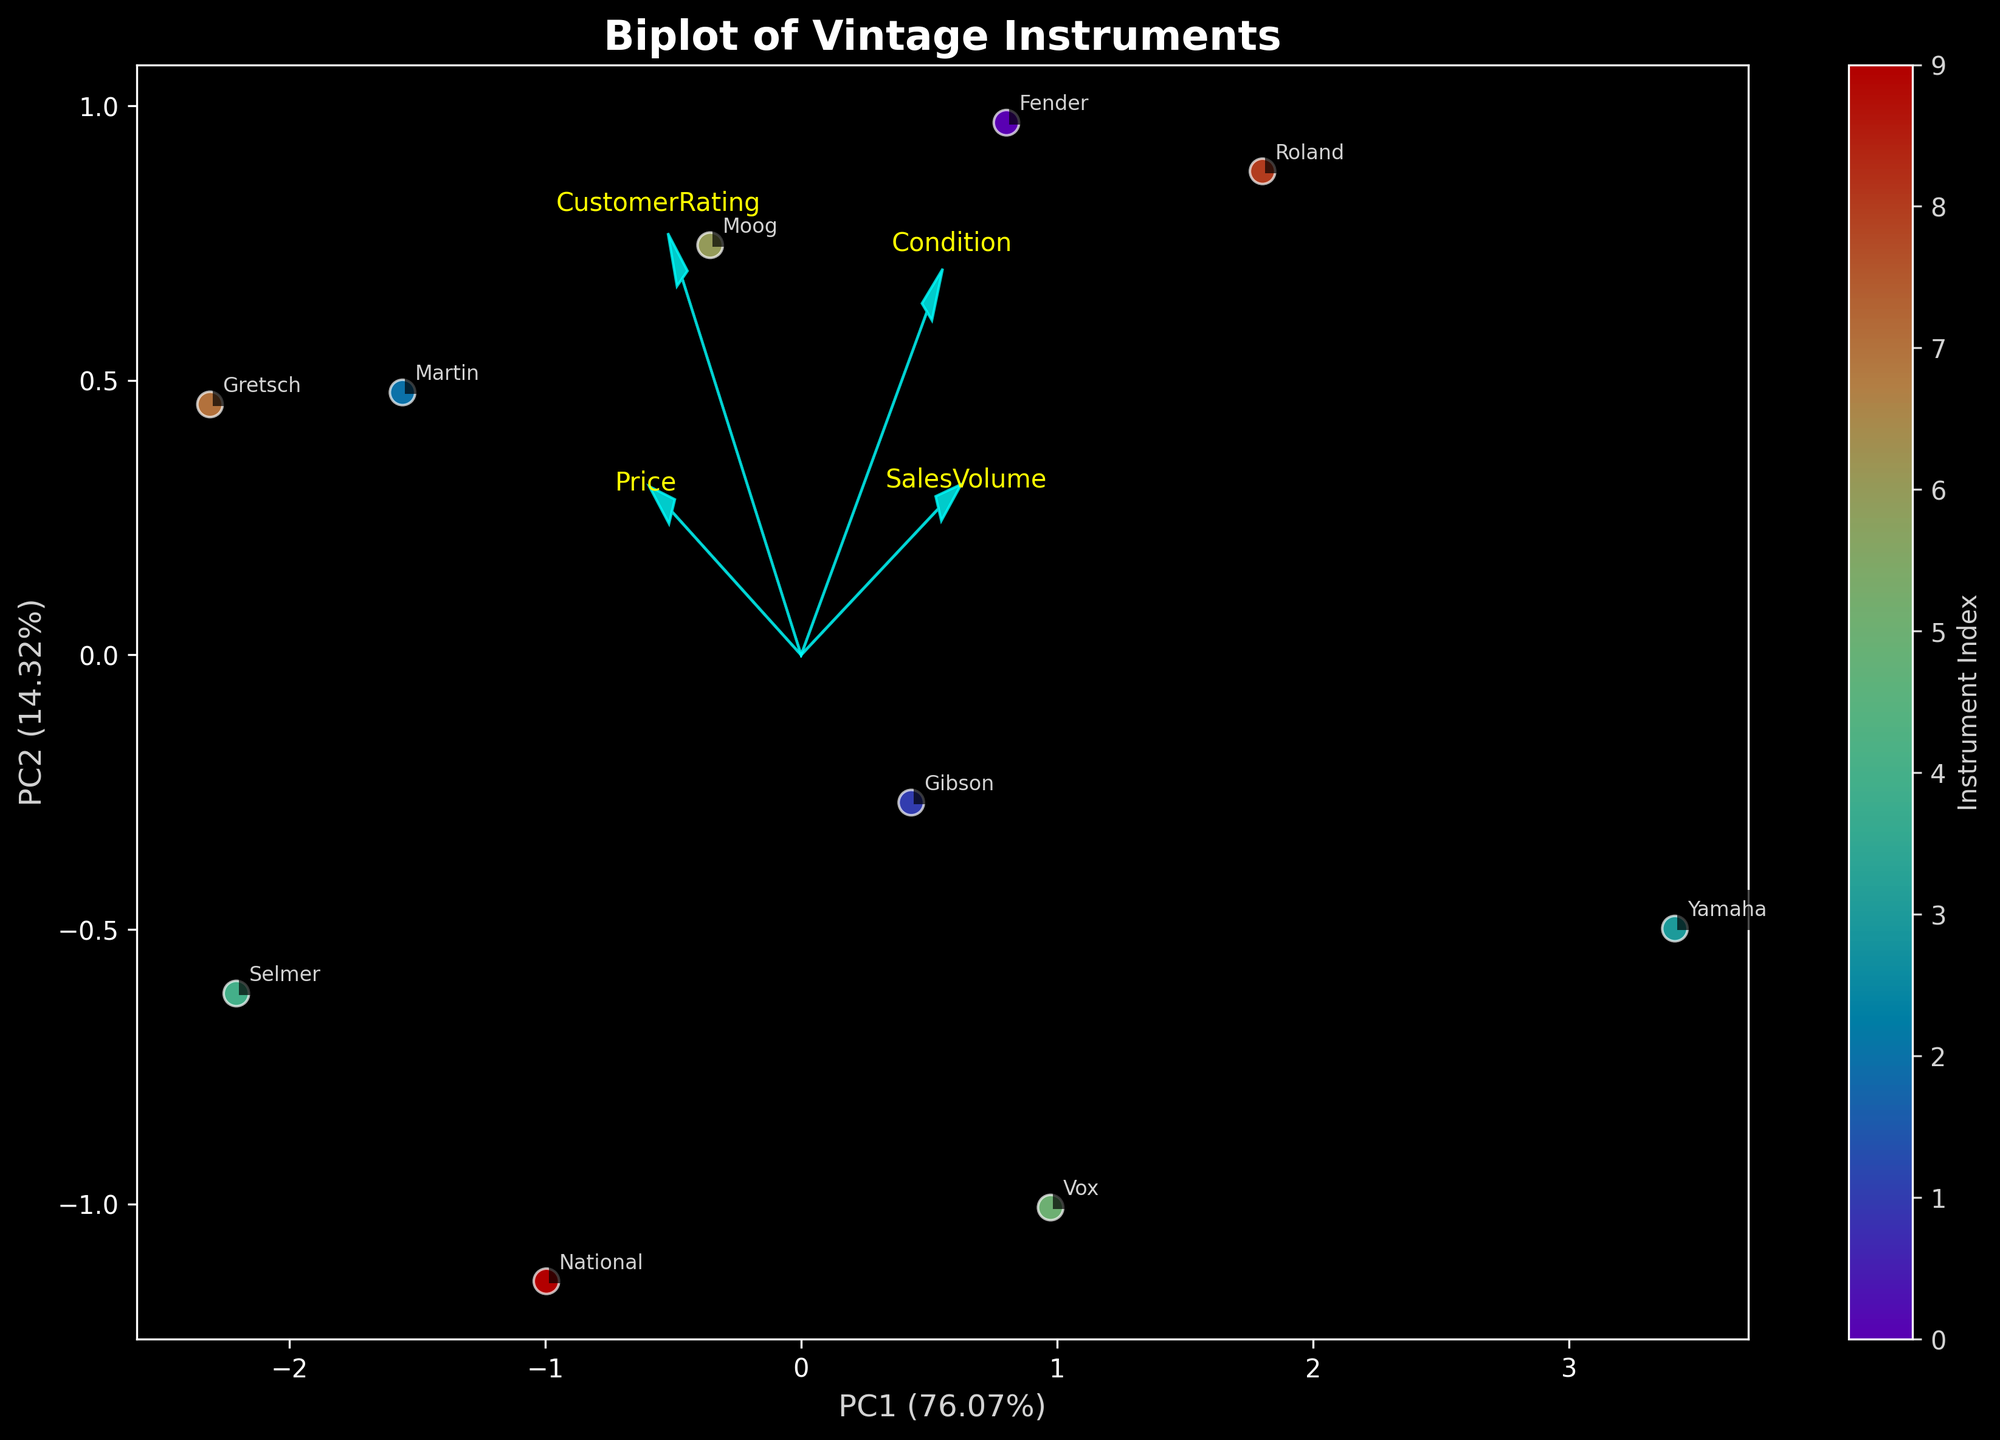What is the title of the figure? The title of the figure is usually displayed prominently at the top. In this case, it says "Biplot of Vintage Instruments."
Answer: Biplot of Vintage Instruments What are the axes labels? The axes labels represent the principal components and their explained variance. They are "PC1" and "PC2" with percentages indicating variance explained.
Answer: PC1 and PC2 How many data points are represented in the figure? Each instrument is a data point, and the number of data points equals the number of instruments. There are 10 instruments listed in the data, so there are 10 data points.
Answer: 10 Which brand appears most towards the right on PC1? By looking for the data point with the highest value on the PC1 axis on the right, we see that "Yamaha" is the furthest to the right.
Answer: Yamaha Which component (PC1 or PC2) explains the larger percentage of variance? The axes labels provide the explained variance percentages. The label for PC1 shows it explains more variance than PC2.
Answer: PC1 Which feature vector points most upward along the vertical axis? By observing the directions of the arrows for each feature, the "Price" arrow points most upward along the vertical axis.
Answer: Price Which instrument likely has the highest condition rating? The condition feature vector's direction can help deduce this. Instruments closer to the positive end of the condition vector likely have higher ratings. The "Roland TR-808" and "Yamaha DX7" appear close to this direction, but among them, the Yamaha DX7 has a condition rating of 9, which is the highest.
Answer: Yamaha DX7 How do "SalesVolume" and "CustomerRating" relate to each other? Analyze the direction and proximity of the vectors. The vectors for "SalesVolume" and "CustomerRating" point in similar directions, indicating a positive correlation.
Answer: Positively correlated Which instrument brand is closest to where the "Price" vector points? By locating the direction in which the "Price" arrow points, the "Selmer" and "Gretsch" brands are nearest to this vector.
Answer: Selmer and Gretsch What does the color bar represent? The color bar next to the figure typically represents a continuous variable. Here, it indicates the index of each instrument, providing additional information about the individual data points' identifiers.
Answer: Instrument Index 